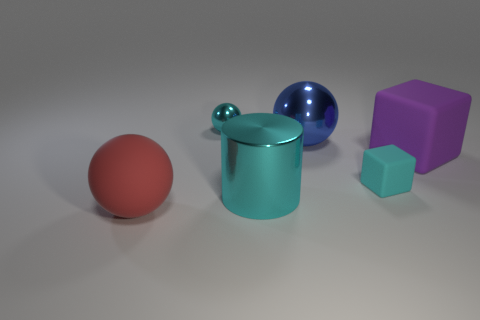Subtract all large rubber balls. How many balls are left? 2 Add 1 big blue balls. How many objects exist? 7 Subtract 2 cubes. How many cubes are left? 0 Subtract all cubes. How many objects are left? 4 Add 3 large red matte objects. How many large red matte objects are left? 4 Add 1 purple rubber balls. How many purple rubber balls exist? 1 Subtract 0 yellow cylinders. How many objects are left? 6 Subtract all purple spheres. Subtract all gray cylinders. How many spheres are left? 3 Subtract all big things. Subtract all tiny yellow rubber cylinders. How many objects are left? 2 